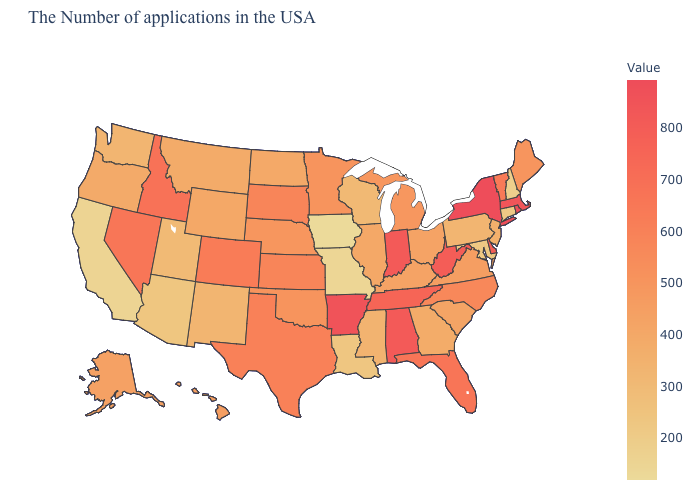Does Iowa have the lowest value in the MidWest?
Concise answer only. Yes. Which states have the lowest value in the USA?
Give a very brief answer. Iowa. Which states hav the highest value in the MidWest?
Be succinct. Indiana. Does Iowa have the lowest value in the USA?
Give a very brief answer. Yes. Which states have the lowest value in the Northeast?
Answer briefly. New Hampshire. Among the states that border New Mexico , which have the lowest value?
Write a very short answer. Arizona. 